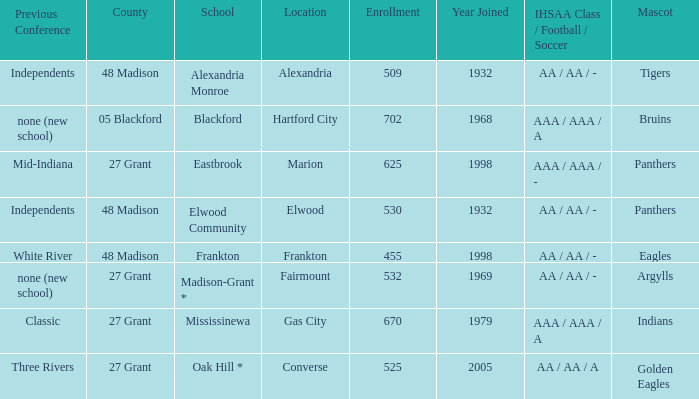What is the previous conference when the location is converse? Three Rivers. 